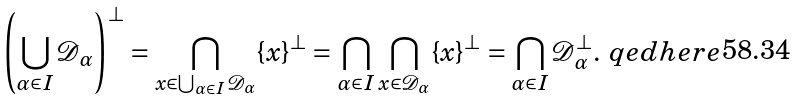Convert formula to latex. <formula><loc_0><loc_0><loc_500><loc_500>\left ( \bigcup _ { \alpha \in I } \mathcal { D } _ { \alpha } \right ) ^ { \perp } = \bigcap _ { x \in \bigcup _ { \alpha \in I } \mathcal { D } _ { \alpha } } \{ x \} ^ { \perp } = \bigcap _ { \alpha \in I } \bigcap _ { x \in \mathcal { D } _ { \alpha } } \{ x \} ^ { \perp } = \bigcap _ { \alpha \in I } \mathcal { D } _ { \alpha } ^ { \perp } . & \ q e d h e r e</formula> 